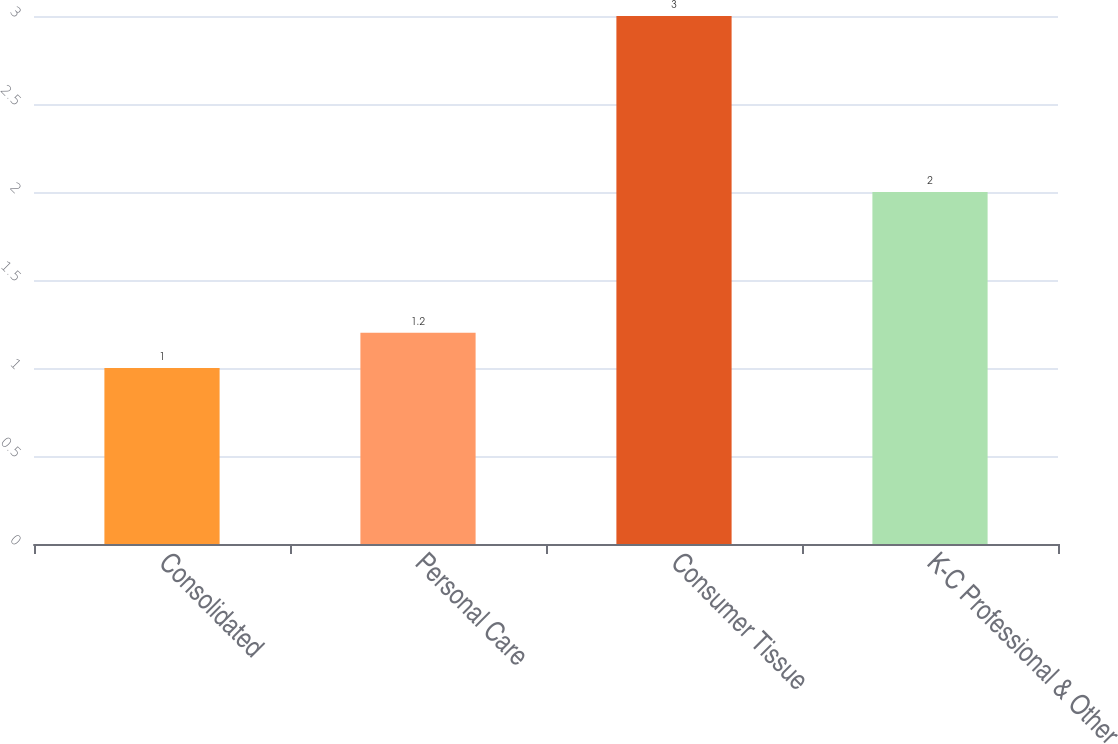<chart> <loc_0><loc_0><loc_500><loc_500><bar_chart><fcel>Consolidated<fcel>Personal Care<fcel>Consumer Tissue<fcel>K-C Professional & Other<nl><fcel>1<fcel>1.2<fcel>3<fcel>2<nl></chart> 